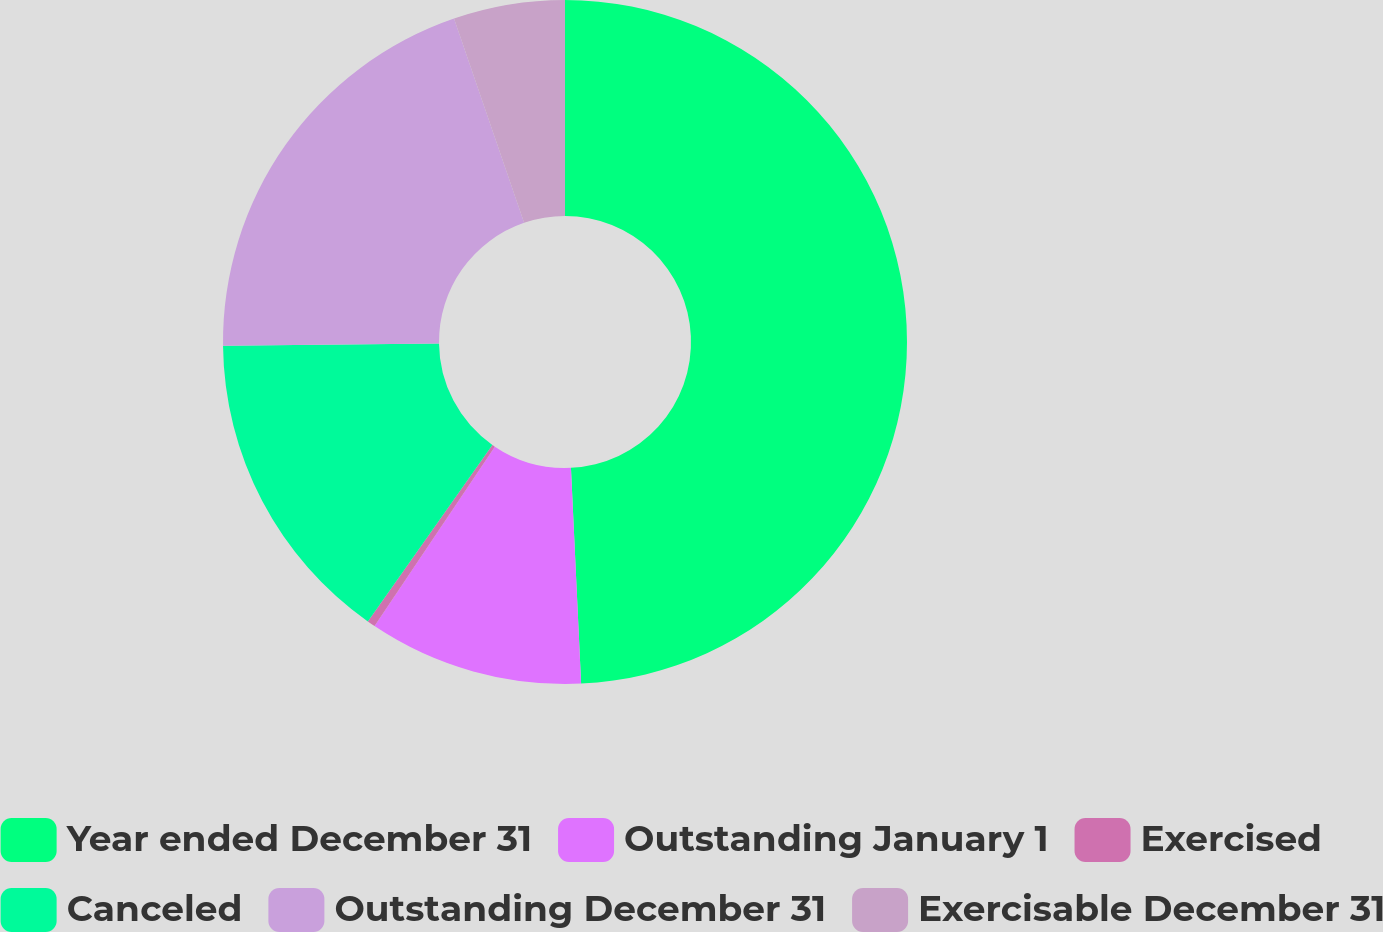<chart> <loc_0><loc_0><loc_500><loc_500><pie_chart><fcel>Year ended December 31<fcel>Outstanding January 1<fcel>Exercised<fcel>Canceled<fcel>Outstanding December 31<fcel>Exercisable December 31<nl><fcel>49.25%<fcel>10.15%<fcel>0.38%<fcel>15.04%<fcel>19.92%<fcel>5.26%<nl></chart> 